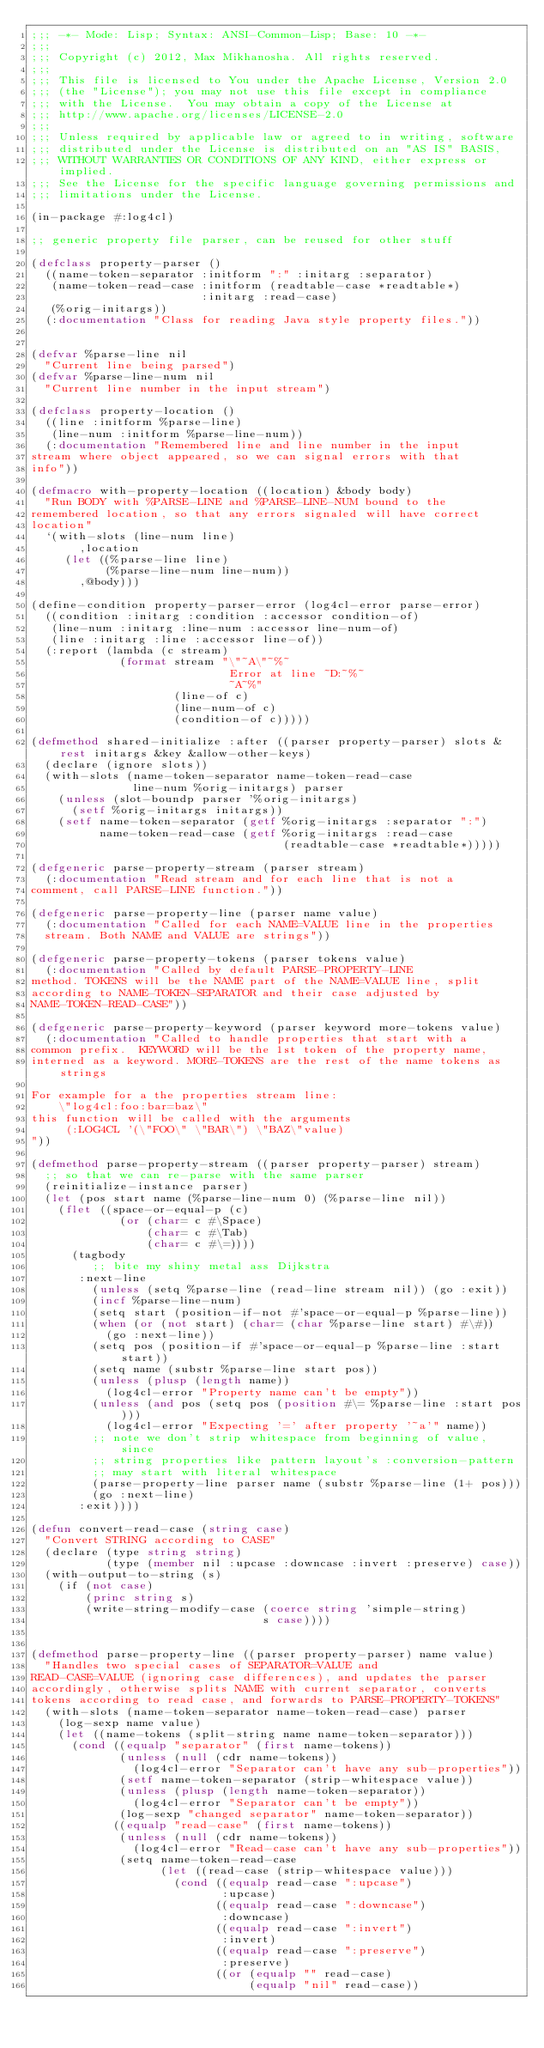Convert code to text. <code><loc_0><loc_0><loc_500><loc_500><_Lisp_>;;; -*- Mode: Lisp; Syntax: ANSI-Common-Lisp; Base: 10 -*-
;;;
;;; Copyright (c) 2012, Max Mikhanosha. All rights reserved.
;;;
;;; This file is licensed to You under the Apache License, Version 2.0
;;; (the "License"); you may not use this file except in compliance
;;; with the License.  You may obtain a copy of the License at
;;; http://www.apache.org/licenses/LICENSE-2.0
;;;
;;; Unless required by applicable law or agreed to in writing, software
;;; distributed under the License is distributed on an "AS IS" BASIS,
;;; WITHOUT WARRANTIES OR CONDITIONS OF ANY KIND, either express or implied.
;;; See the License for the specific language governing permissions and
;;; limitations under the License.

(in-package #:log4cl)

;; generic property file parser, can be reused for other stuff

(defclass property-parser ()
  ((name-token-separator :initform ":" :initarg :separator)
   (name-token-read-case :initform (readtable-case *readtable*)
                         :initarg :read-case)
   (%orig-initargs))
  (:documentation "Class for reading Java style property files."))


(defvar %parse-line nil
  "Current line being parsed")
(defvar %parse-line-num nil
  "Current line number in the input stream")

(defclass property-location ()
  ((line :initform %parse-line)
   (line-num :initform %parse-line-num))
  (:documentation "Remembered line and line number in the input
stream where object appeared, so we can signal errors with that
info"))

(defmacro with-property-location ((location) &body body)
  "Run BODY with %PARSE-LINE and %PARSE-LINE-NUM bound to the
remembered location, so that any errors signaled will have correct
location"
  `(with-slots (line-num line)
       ,location
     (let ((%parse-line line)
           (%parse-line-num line-num))
       ,@body)))

(define-condition property-parser-error (log4cl-error parse-error)
  ((condition :initarg :condition :accessor condition-of)
   (line-num :initarg :line-num :accessor line-num-of)
   (line :initarg :line :accessor line-of))
  (:report (lambda (c stream)
             (format stream "\"~A\"~%~
                             Error at line ~D:~%~
                             ~A~%"
                     (line-of c)
                     (line-num-of c)
                     (condition-of c)))))

(defmethod shared-initialize :after ((parser property-parser) slots &rest initargs &key &allow-other-keys)
  (declare (ignore slots))
  (with-slots (name-token-separator name-token-read-case
               line-num %orig-initargs) parser
    (unless (slot-boundp parser '%orig-initargs)
      (setf %orig-initargs initargs))
    (setf name-token-separator (getf %orig-initargs :separator ":")
          name-token-read-case (getf %orig-initargs :read-case
                                     (readtable-case *readtable*)))))

(defgeneric parse-property-stream (parser stream)
  (:documentation "Read stream and for each line that is not a
comment, call PARSE-LINE function."))

(defgeneric parse-property-line (parser name value)
  (:documentation "Called for each NAME=VALUE line in the properties
  stream. Both NAME and VALUE are strings"))

(defgeneric parse-property-tokens (parser tokens value)
  (:documentation "Called by default PARSE-PROPERTY-LINE
method. TOKENS will be the NAME part of the NAME=VALUE line, split
according to NAME-TOKEN-SEPARATOR and their case adjusted by
NAME-TOKEN-READ-CASE"))

(defgeneric parse-property-keyword (parser keyword more-tokens value)
  (:documentation "Called to handle properties that start with a
common prefix.  KEYWORD will be the 1st token of the property name,
interned as a keyword. MORE-TOKENS are the rest of the name tokens as strings

For example for a the properties stream line:
    \"log4cl:foo:bar=baz\"
this function will be called with the arguments
     (:LOG4CL '(\"FOO\" \"BAR\") \"BAZ\"value)
"))

(defmethod parse-property-stream ((parser property-parser) stream)
  ;; so that we can re-parse with the same parser
  (reinitialize-instance parser)
  (let (pos start name (%parse-line-num 0) (%parse-line nil))
    (flet ((space-or-equal-p (c)
             (or (char= c #\Space)
                 (char= c #\Tab)
                 (char= c #\=))))
      (tagbody  
         ;; bite my shiny metal ass Dijkstra
       :next-line 
         (unless (setq %parse-line (read-line stream nil)) (go :exit))
         (incf %parse-line-num)
         (setq start (position-if-not #'space-or-equal-p %parse-line))
         (when (or (not start) (char= (char %parse-line start) #\#))
           (go :next-line))
         (setq pos (position-if #'space-or-equal-p %parse-line :start start))
         (setq name (substr %parse-line start pos))
         (unless (plusp (length name))
           (log4cl-error "Property name can't be empty"))
         (unless (and pos (setq pos (position #\= %parse-line :start pos)))
           (log4cl-error "Expecting '=' after property '~a'" name))
         ;; note we don't strip whitespace from beginning of value, since
         ;; string properties like pattern layout's :conversion-pattern
         ;; may start with literal whitespace
         (parse-property-line parser name (substr %parse-line (1+ pos)))
         (go :next-line)
       :exit))))

(defun convert-read-case (string case)
  "Convert STRING according to CASE"
  (declare (type string string)
           (type (member nil :upcase :downcase :invert :preserve) case))
  (with-output-to-string (s)
    (if (not case)
        (princ string s)
        (write-string-modify-case (coerce string 'simple-string)
                                  s case))))


(defmethod parse-property-line ((parser property-parser) name value)
  "Handles two special cases of SEPARATOR=VALUE and
READ-CASE=VALUE (ignoring case differences), and updates the parser
accordingly, otherwise splits NAME with current separator, converts
tokens according to read case, and forwards to PARSE-PROPERTY-TOKENS"
  (with-slots (name-token-separator name-token-read-case) parser
    (log-sexp name value)
    (let ((name-tokens (split-string name name-token-separator)))
      (cond ((equalp "separator" (first name-tokens))
             (unless (null (cdr name-tokens))
               (log4cl-error "Separator can't have any sub-properties"))
             (setf name-token-separator (strip-whitespace value))
             (unless (plusp (length name-token-separator))
               (log4cl-error "Separator can't be empty"))
             (log-sexp "changed separator" name-token-separator))
            ((equalp "read-case" (first name-tokens))
             (unless (null (cdr name-tokens))
               (log4cl-error "Read-case can't have any sub-properties"))
             (setq name-token-read-case
                   (let ((read-case (strip-whitespace value)))
                     (cond ((equalp read-case ":upcase")
                            :upcase)
                           ((equalp read-case ":downcase")
                            :downcase)
                           ((equalp read-case ":invert")
                            :invert)
                           ((equalp read-case ":preserve")
                            :preserve)
                           ((or (equalp "" read-case)
                                (equalp "nil" read-case))</code> 